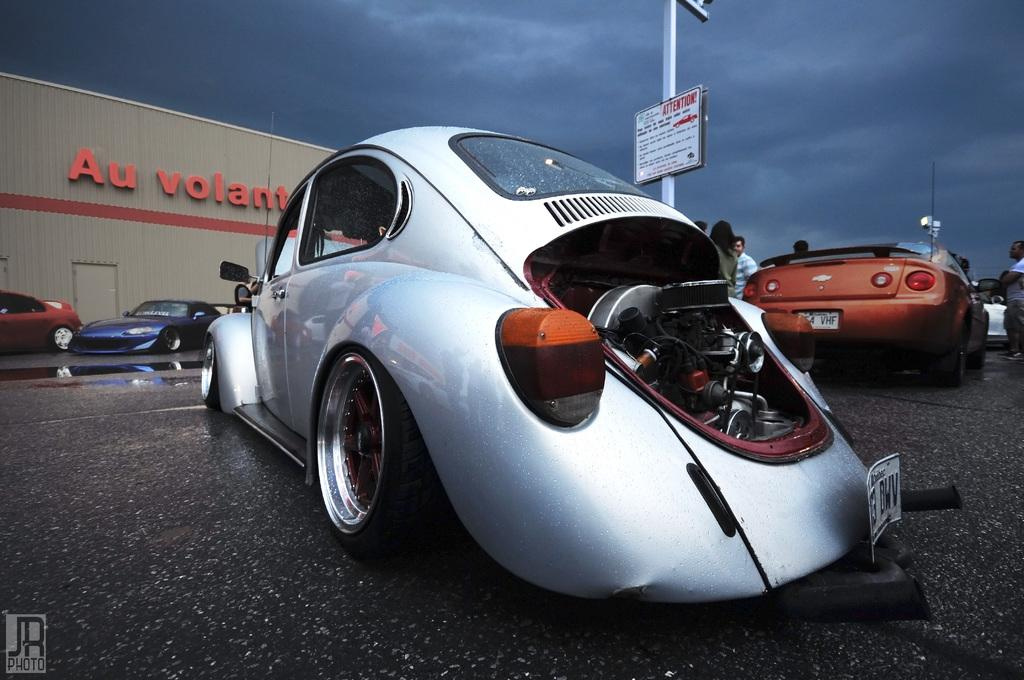What type of vehicles can be seen in the image? There are cars in the image. What are the people in the image doing? There is a group of people standing on the road. What can be seen in the background of the image? There is a board and a pole in the background of the image. What is visible in the sky in the image? The sky is visible in the background of the image, and clouds are present. What type of reward is being given to the hen in the image? There is no hen present in the image, so no reward can be given. What type of rail is visible in the image? There is no rail visible in the image. 